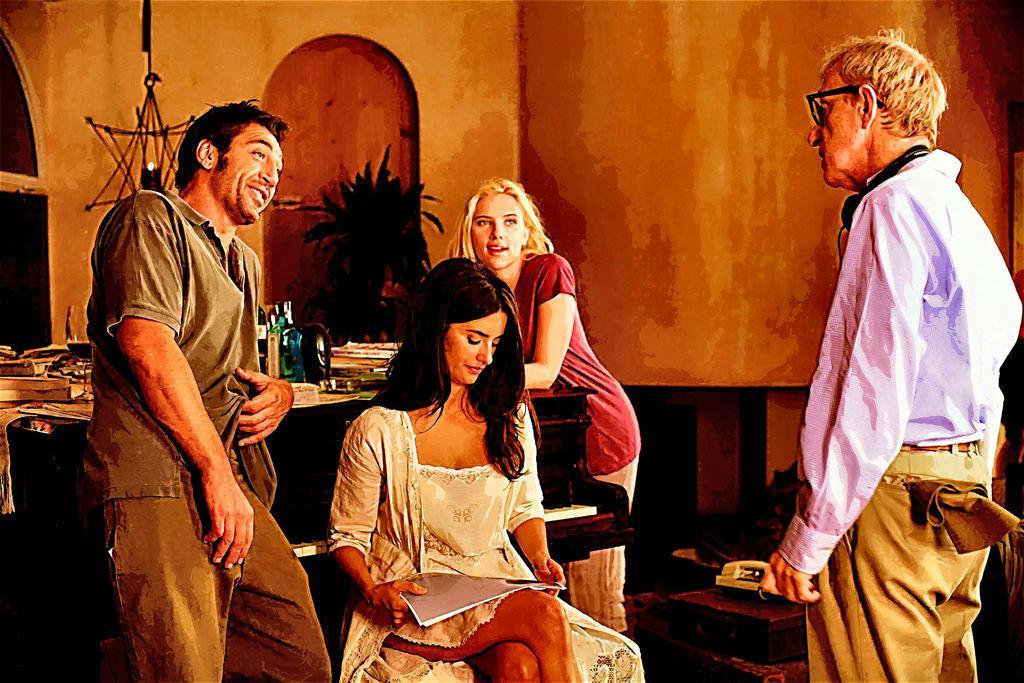How would you summarize this image in a sentence or two? This picture is clicked inside the room. The woman in the middle of the picture wearing white dress is sitting on the stool and she is holding a book in her hands. Beside her, there are three people standing. Behind her, we see a table on which books, papers and bottles are placed. Behind that, we see a wall and a door. At the bottom of the picture, we see a table on which landline phone is placed. 